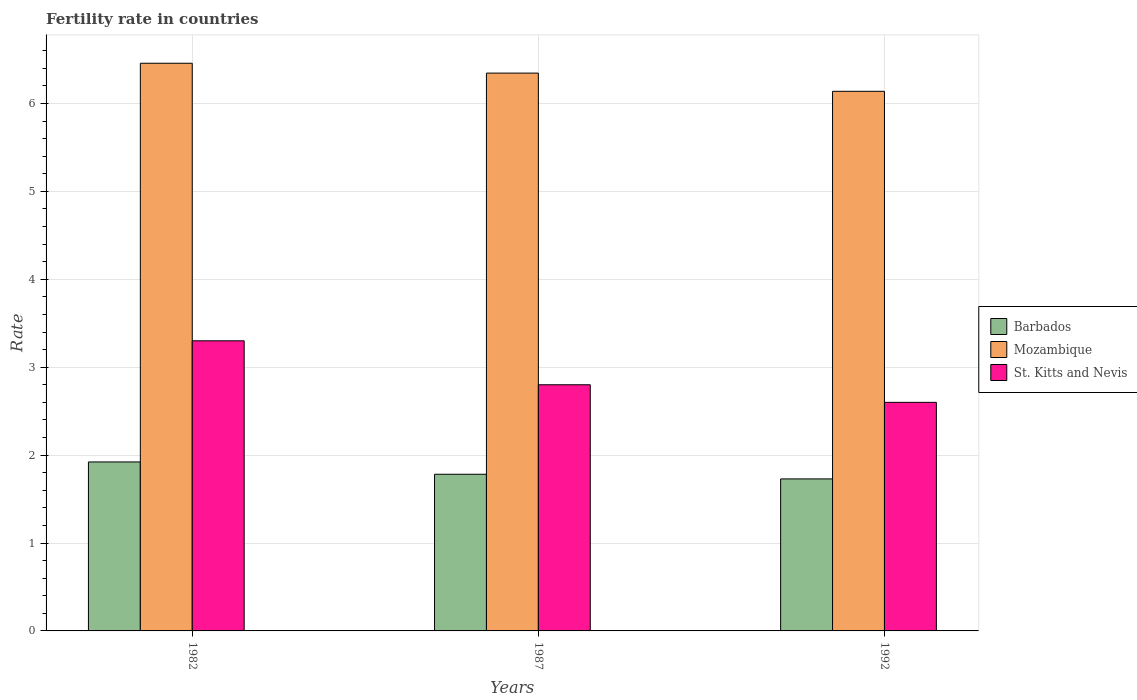How many different coloured bars are there?
Give a very brief answer. 3. Are the number of bars per tick equal to the number of legend labels?
Your answer should be very brief. Yes. Are the number of bars on each tick of the X-axis equal?
Keep it short and to the point. Yes. What is the label of the 1st group of bars from the left?
Your answer should be compact. 1982. In how many cases, is the number of bars for a given year not equal to the number of legend labels?
Your answer should be compact. 0. What is the fertility rate in Mozambique in 1987?
Your response must be concise. 6.34. Across all years, what is the maximum fertility rate in Mozambique?
Provide a short and direct response. 6.46. Across all years, what is the minimum fertility rate in St. Kitts and Nevis?
Keep it short and to the point. 2.6. In which year was the fertility rate in Mozambique minimum?
Your answer should be very brief. 1992. What is the total fertility rate in Mozambique in the graph?
Offer a very short reply. 18.94. What is the difference between the fertility rate in Barbados in 1987 and that in 1992?
Ensure brevity in your answer.  0.05. What is the difference between the fertility rate in Barbados in 1992 and the fertility rate in Mozambique in 1982?
Provide a short and direct response. -4.73. What is the average fertility rate in Barbados per year?
Keep it short and to the point. 1.81. In the year 1992, what is the difference between the fertility rate in Barbados and fertility rate in St. Kitts and Nevis?
Your answer should be very brief. -0.87. What is the ratio of the fertility rate in St. Kitts and Nevis in 1982 to that in 1987?
Provide a succinct answer. 1.18. Is the fertility rate in St. Kitts and Nevis in 1982 less than that in 1992?
Your answer should be very brief. No. Is the difference between the fertility rate in Barbados in 1982 and 1992 greater than the difference between the fertility rate in St. Kitts and Nevis in 1982 and 1992?
Keep it short and to the point. No. What is the difference between the highest and the second highest fertility rate in Barbados?
Keep it short and to the point. 0.14. What is the difference between the highest and the lowest fertility rate in Mozambique?
Provide a succinct answer. 0.32. Is the sum of the fertility rate in Mozambique in 1987 and 1992 greater than the maximum fertility rate in Barbados across all years?
Offer a terse response. Yes. What does the 2nd bar from the left in 1987 represents?
Your answer should be very brief. Mozambique. What does the 2nd bar from the right in 1992 represents?
Make the answer very short. Mozambique. What is the difference between two consecutive major ticks on the Y-axis?
Offer a very short reply. 1. Does the graph contain any zero values?
Your response must be concise. No. What is the title of the graph?
Offer a very short reply. Fertility rate in countries. What is the label or title of the X-axis?
Make the answer very short. Years. What is the label or title of the Y-axis?
Your answer should be very brief. Rate. What is the Rate of Barbados in 1982?
Offer a terse response. 1.92. What is the Rate in Mozambique in 1982?
Ensure brevity in your answer.  6.46. What is the Rate of St. Kitts and Nevis in 1982?
Your response must be concise. 3.3. What is the Rate in Barbados in 1987?
Your answer should be very brief. 1.78. What is the Rate of Mozambique in 1987?
Ensure brevity in your answer.  6.34. What is the Rate of Barbados in 1992?
Offer a very short reply. 1.73. What is the Rate of Mozambique in 1992?
Make the answer very short. 6.14. Across all years, what is the maximum Rate of Barbados?
Your answer should be very brief. 1.92. Across all years, what is the maximum Rate in Mozambique?
Offer a terse response. 6.46. Across all years, what is the maximum Rate of St. Kitts and Nevis?
Make the answer very short. 3.3. Across all years, what is the minimum Rate in Barbados?
Ensure brevity in your answer.  1.73. Across all years, what is the minimum Rate in Mozambique?
Make the answer very short. 6.14. Across all years, what is the minimum Rate in St. Kitts and Nevis?
Your answer should be compact. 2.6. What is the total Rate in Barbados in the graph?
Offer a terse response. 5.43. What is the total Rate of Mozambique in the graph?
Your answer should be very brief. 18.94. What is the total Rate in St. Kitts and Nevis in the graph?
Your answer should be compact. 8.7. What is the difference between the Rate in Barbados in 1982 and that in 1987?
Your answer should be compact. 0.14. What is the difference between the Rate of Mozambique in 1982 and that in 1987?
Provide a succinct answer. 0.11. What is the difference between the Rate in Barbados in 1982 and that in 1992?
Your answer should be compact. 0.19. What is the difference between the Rate of Mozambique in 1982 and that in 1992?
Make the answer very short. 0.32. What is the difference between the Rate in Barbados in 1987 and that in 1992?
Give a very brief answer. 0.05. What is the difference between the Rate in Mozambique in 1987 and that in 1992?
Your answer should be compact. 0.21. What is the difference between the Rate of Barbados in 1982 and the Rate of Mozambique in 1987?
Offer a terse response. -4.42. What is the difference between the Rate of Barbados in 1982 and the Rate of St. Kitts and Nevis in 1987?
Keep it short and to the point. -0.88. What is the difference between the Rate in Mozambique in 1982 and the Rate in St. Kitts and Nevis in 1987?
Your answer should be very brief. 3.66. What is the difference between the Rate of Barbados in 1982 and the Rate of Mozambique in 1992?
Your response must be concise. -4.22. What is the difference between the Rate of Barbados in 1982 and the Rate of St. Kitts and Nevis in 1992?
Provide a succinct answer. -0.68. What is the difference between the Rate of Mozambique in 1982 and the Rate of St. Kitts and Nevis in 1992?
Ensure brevity in your answer.  3.86. What is the difference between the Rate of Barbados in 1987 and the Rate of Mozambique in 1992?
Keep it short and to the point. -4.36. What is the difference between the Rate of Barbados in 1987 and the Rate of St. Kitts and Nevis in 1992?
Provide a short and direct response. -0.82. What is the difference between the Rate of Mozambique in 1987 and the Rate of St. Kitts and Nevis in 1992?
Give a very brief answer. 3.75. What is the average Rate of Barbados per year?
Provide a short and direct response. 1.81. What is the average Rate of Mozambique per year?
Provide a succinct answer. 6.31. In the year 1982, what is the difference between the Rate in Barbados and Rate in Mozambique?
Make the answer very short. -4.54. In the year 1982, what is the difference between the Rate in Barbados and Rate in St. Kitts and Nevis?
Provide a succinct answer. -1.38. In the year 1982, what is the difference between the Rate of Mozambique and Rate of St. Kitts and Nevis?
Offer a very short reply. 3.16. In the year 1987, what is the difference between the Rate in Barbados and Rate in Mozambique?
Offer a very short reply. -4.56. In the year 1987, what is the difference between the Rate in Barbados and Rate in St. Kitts and Nevis?
Your response must be concise. -1.02. In the year 1987, what is the difference between the Rate in Mozambique and Rate in St. Kitts and Nevis?
Offer a terse response. 3.54. In the year 1992, what is the difference between the Rate in Barbados and Rate in Mozambique?
Ensure brevity in your answer.  -4.41. In the year 1992, what is the difference between the Rate in Barbados and Rate in St. Kitts and Nevis?
Your response must be concise. -0.87. In the year 1992, what is the difference between the Rate of Mozambique and Rate of St. Kitts and Nevis?
Give a very brief answer. 3.54. What is the ratio of the Rate of Barbados in 1982 to that in 1987?
Keep it short and to the point. 1.08. What is the ratio of the Rate in Mozambique in 1982 to that in 1987?
Offer a terse response. 1.02. What is the ratio of the Rate in St. Kitts and Nevis in 1982 to that in 1987?
Your answer should be compact. 1.18. What is the ratio of the Rate of Barbados in 1982 to that in 1992?
Provide a short and direct response. 1.11. What is the ratio of the Rate in Mozambique in 1982 to that in 1992?
Give a very brief answer. 1.05. What is the ratio of the Rate of St. Kitts and Nevis in 1982 to that in 1992?
Provide a succinct answer. 1.27. What is the ratio of the Rate in Barbados in 1987 to that in 1992?
Provide a short and direct response. 1.03. What is the ratio of the Rate in Mozambique in 1987 to that in 1992?
Provide a short and direct response. 1.03. What is the difference between the highest and the second highest Rate of Barbados?
Offer a very short reply. 0.14. What is the difference between the highest and the second highest Rate of Mozambique?
Make the answer very short. 0.11. What is the difference between the highest and the second highest Rate of St. Kitts and Nevis?
Your response must be concise. 0.5. What is the difference between the highest and the lowest Rate in Barbados?
Give a very brief answer. 0.19. What is the difference between the highest and the lowest Rate in Mozambique?
Your answer should be compact. 0.32. 